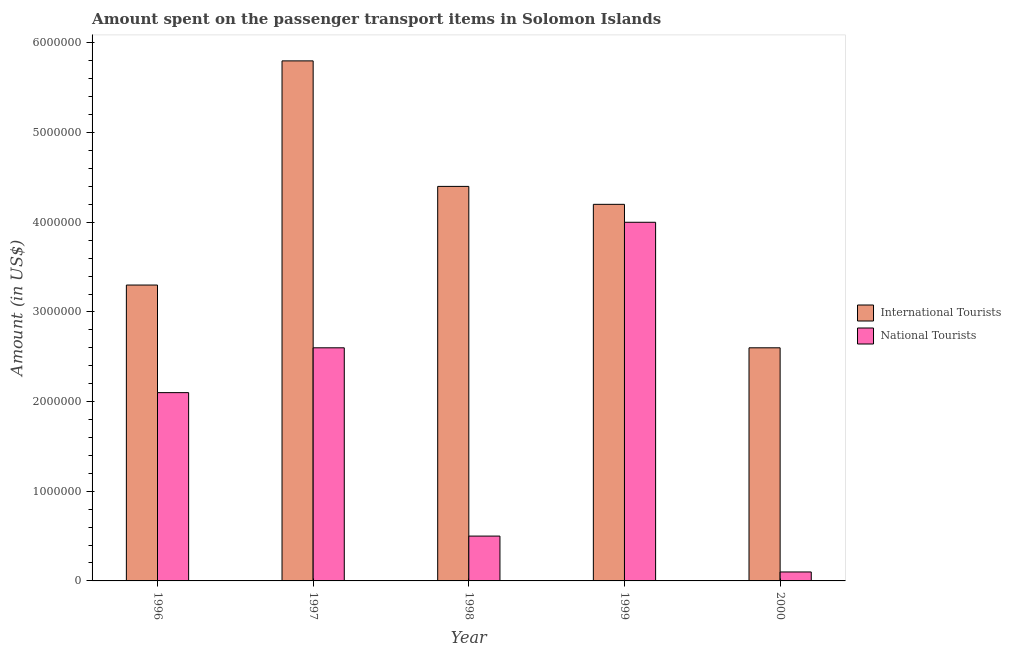How many groups of bars are there?
Give a very brief answer. 5. Are the number of bars per tick equal to the number of legend labels?
Offer a very short reply. Yes. Are the number of bars on each tick of the X-axis equal?
Ensure brevity in your answer.  Yes. How many bars are there on the 3rd tick from the left?
Your answer should be compact. 2. How many bars are there on the 4th tick from the right?
Your answer should be compact. 2. What is the amount spent on transport items of national tourists in 2000?
Your response must be concise. 1.00e+05. Across all years, what is the maximum amount spent on transport items of national tourists?
Keep it short and to the point. 4.00e+06. Across all years, what is the minimum amount spent on transport items of national tourists?
Your answer should be very brief. 1.00e+05. What is the total amount spent on transport items of international tourists in the graph?
Keep it short and to the point. 2.03e+07. What is the difference between the amount spent on transport items of national tourists in 1997 and that in 1998?
Provide a succinct answer. 2.10e+06. What is the difference between the amount spent on transport items of international tourists in 2000 and the amount spent on transport items of national tourists in 1997?
Give a very brief answer. -3.20e+06. What is the average amount spent on transport items of international tourists per year?
Provide a succinct answer. 4.06e+06. What is the ratio of the amount spent on transport items of international tourists in 1998 to that in 2000?
Your answer should be very brief. 1.69. What is the difference between the highest and the second highest amount spent on transport items of national tourists?
Your answer should be compact. 1.40e+06. What is the difference between the highest and the lowest amount spent on transport items of national tourists?
Your answer should be compact. 3.90e+06. Is the sum of the amount spent on transport items of international tourists in 1996 and 1999 greater than the maximum amount spent on transport items of national tourists across all years?
Offer a terse response. Yes. What does the 2nd bar from the left in 1998 represents?
Your response must be concise. National Tourists. What does the 2nd bar from the right in 1999 represents?
Provide a short and direct response. International Tourists. Are all the bars in the graph horizontal?
Provide a succinct answer. No. Are the values on the major ticks of Y-axis written in scientific E-notation?
Your response must be concise. No. Does the graph contain any zero values?
Keep it short and to the point. No. Does the graph contain grids?
Your answer should be compact. No. How many legend labels are there?
Offer a very short reply. 2. How are the legend labels stacked?
Your response must be concise. Vertical. What is the title of the graph?
Provide a short and direct response. Amount spent on the passenger transport items in Solomon Islands. What is the label or title of the Y-axis?
Provide a short and direct response. Amount (in US$). What is the Amount (in US$) in International Tourists in 1996?
Ensure brevity in your answer.  3.30e+06. What is the Amount (in US$) of National Tourists in 1996?
Keep it short and to the point. 2.10e+06. What is the Amount (in US$) of International Tourists in 1997?
Give a very brief answer. 5.80e+06. What is the Amount (in US$) of National Tourists in 1997?
Your answer should be compact. 2.60e+06. What is the Amount (in US$) of International Tourists in 1998?
Ensure brevity in your answer.  4.40e+06. What is the Amount (in US$) of International Tourists in 1999?
Give a very brief answer. 4.20e+06. What is the Amount (in US$) in National Tourists in 1999?
Your answer should be very brief. 4.00e+06. What is the Amount (in US$) of International Tourists in 2000?
Provide a short and direct response. 2.60e+06. What is the Amount (in US$) of National Tourists in 2000?
Offer a very short reply. 1.00e+05. Across all years, what is the maximum Amount (in US$) in International Tourists?
Provide a short and direct response. 5.80e+06. Across all years, what is the maximum Amount (in US$) in National Tourists?
Offer a terse response. 4.00e+06. Across all years, what is the minimum Amount (in US$) of International Tourists?
Provide a succinct answer. 2.60e+06. What is the total Amount (in US$) of International Tourists in the graph?
Your answer should be very brief. 2.03e+07. What is the total Amount (in US$) in National Tourists in the graph?
Your answer should be compact. 9.30e+06. What is the difference between the Amount (in US$) of International Tourists in 1996 and that in 1997?
Your answer should be compact. -2.50e+06. What is the difference between the Amount (in US$) of National Tourists in 1996 and that in 1997?
Keep it short and to the point. -5.00e+05. What is the difference between the Amount (in US$) in International Tourists in 1996 and that in 1998?
Your answer should be compact. -1.10e+06. What is the difference between the Amount (in US$) in National Tourists in 1996 and that in 1998?
Provide a succinct answer. 1.60e+06. What is the difference between the Amount (in US$) in International Tourists in 1996 and that in 1999?
Make the answer very short. -9.00e+05. What is the difference between the Amount (in US$) in National Tourists in 1996 and that in 1999?
Offer a very short reply. -1.90e+06. What is the difference between the Amount (in US$) in National Tourists in 1996 and that in 2000?
Your answer should be very brief. 2.00e+06. What is the difference between the Amount (in US$) of International Tourists in 1997 and that in 1998?
Provide a succinct answer. 1.40e+06. What is the difference between the Amount (in US$) in National Tourists in 1997 and that in 1998?
Ensure brevity in your answer.  2.10e+06. What is the difference between the Amount (in US$) of International Tourists in 1997 and that in 1999?
Your response must be concise. 1.60e+06. What is the difference between the Amount (in US$) of National Tourists in 1997 and that in 1999?
Provide a succinct answer. -1.40e+06. What is the difference between the Amount (in US$) of International Tourists in 1997 and that in 2000?
Ensure brevity in your answer.  3.20e+06. What is the difference between the Amount (in US$) of National Tourists in 1997 and that in 2000?
Keep it short and to the point. 2.50e+06. What is the difference between the Amount (in US$) of National Tourists in 1998 and that in 1999?
Your response must be concise. -3.50e+06. What is the difference between the Amount (in US$) in International Tourists in 1998 and that in 2000?
Make the answer very short. 1.80e+06. What is the difference between the Amount (in US$) in International Tourists in 1999 and that in 2000?
Keep it short and to the point. 1.60e+06. What is the difference between the Amount (in US$) of National Tourists in 1999 and that in 2000?
Provide a short and direct response. 3.90e+06. What is the difference between the Amount (in US$) of International Tourists in 1996 and the Amount (in US$) of National Tourists in 1998?
Make the answer very short. 2.80e+06. What is the difference between the Amount (in US$) in International Tourists in 1996 and the Amount (in US$) in National Tourists in 1999?
Your answer should be very brief. -7.00e+05. What is the difference between the Amount (in US$) of International Tourists in 1996 and the Amount (in US$) of National Tourists in 2000?
Offer a terse response. 3.20e+06. What is the difference between the Amount (in US$) of International Tourists in 1997 and the Amount (in US$) of National Tourists in 1998?
Keep it short and to the point. 5.30e+06. What is the difference between the Amount (in US$) in International Tourists in 1997 and the Amount (in US$) in National Tourists in 1999?
Keep it short and to the point. 1.80e+06. What is the difference between the Amount (in US$) of International Tourists in 1997 and the Amount (in US$) of National Tourists in 2000?
Make the answer very short. 5.70e+06. What is the difference between the Amount (in US$) in International Tourists in 1998 and the Amount (in US$) in National Tourists in 2000?
Offer a terse response. 4.30e+06. What is the difference between the Amount (in US$) of International Tourists in 1999 and the Amount (in US$) of National Tourists in 2000?
Provide a succinct answer. 4.10e+06. What is the average Amount (in US$) in International Tourists per year?
Ensure brevity in your answer.  4.06e+06. What is the average Amount (in US$) of National Tourists per year?
Provide a short and direct response. 1.86e+06. In the year 1996, what is the difference between the Amount (in US$) in International Tourists and Amount (in US$) in National Tourists?
Your answer should be very brief. 1.20e+06. In the year 1997, what is the difference between the Amount (in US$) in International Tourists and Amount (in US$) in National Tourists?
Offer a very short reply. 3.20e+06. In the year 1998, what is the difference between the Amount (in US$) in International Tourists and Amount (in US$) in National Tourists?
Ensure brevity in your answer.  3.90e+06. In the year 1999, what is the difference between the Amount (in US$) in International Tourists and Amount (in US$) in National Tourists?
Ensure brevity in your answer.  2.00e+05. In the year 2000, what is the difference between the Amount (in US$) in International Tourists and Amount (in US$) in National Tourists?
Make the answer very short. 2.50e+06. What is the ratio of the Amount (in US$) in International Tourists in 1996 to that in 1997?
Your response must be concise. 0.57. What is the ratio of the Amount (in US$) of National Tourists in 1996 to that in 1997?
Offer a terse response. 0.81. What is the ratio of the Amount (in US$) of International Tourists in 1996 to that in 1998?
Ensure brevity in your answer.  0.75. What is the ratio of the Amount (in US$) of National Tourists in 1996 to that in 1998?
Ensure brevity in your answer.  4.2. What is the ratio of the Amount (in US$) of International Tourists in 1996 to that in 1999?
Your response must be concise. 0.79. What is the ratio of the Amount (in US$) in National Tourists in 1996 to that in 1999?
Your answer should be compact. 0.53. What is the ratio of the Amount (in US$) of International Tourists in 1996 to that in 2000?
Your answer should be compact. 1.27. What is the ratio of the Amount (in US$) in National Tourists in 1996 to that in 2000?
Ensure brevity in your answer.  21. What is the ratio of the Amount (in US$) in International Tourists in 1997 to that in 1998?
Offer a very short reply. 1.32. What is the ratio of the Amount (in US$) in National Tourists in 1997 to that in 1998?
Make the answer very short. 5.2. What is the ratio of the Amount (in US$) in International Tourists in 1997 to that in 1999?
Your response must be concise. 1.38. What is the ratio of the Amount (in US$) in National Tourists in 1997 to that in 1999?
Offer a terse response. 0.65. What is the ratio of the Amount (in US$) of International Tourists in 1997 to that in 2000?
Keep it short and to the point. 2.23. What is the ratio of the Amount (in US$) in National Tourists in 1997 to that in 2000?
Ensure brevity in your answer.  26. What is the ratio of the Amount (in US$) in International Tourists in 1998 to that in 1999?
Make the answer very short. 1.05. What is the ratio of the Amount (in US$) in International Tourists in 1998 to that in 2000?
Make the answer very short. 1.69. What is the ratio of the Amount (in US$) of National Tourists in 1998 to that in 2000?
Offer a very short reply. 5. What is the ratio of the Amount (in US$) in International Tourists in 1999 to that in 2000?
Make the answer very short. 1.62. What is the difference between the highest and the second highest Amount (in US$) in International Tourists?
Make the answer very short. 1.40e+06. What is the difference between the highest and the second highest Amount (in US$) in National Tourists?
Ensure brevity in your answer.  1.40e+06. What is the difference between the highest and the lowest Amount (in US$) of International Tourists?
Your answer should be compact. 3.20e+06. What is the difference between the highest and the lowest Amount (in US$) in National Tourists?
Offer a terse response. 3.90e+06. 